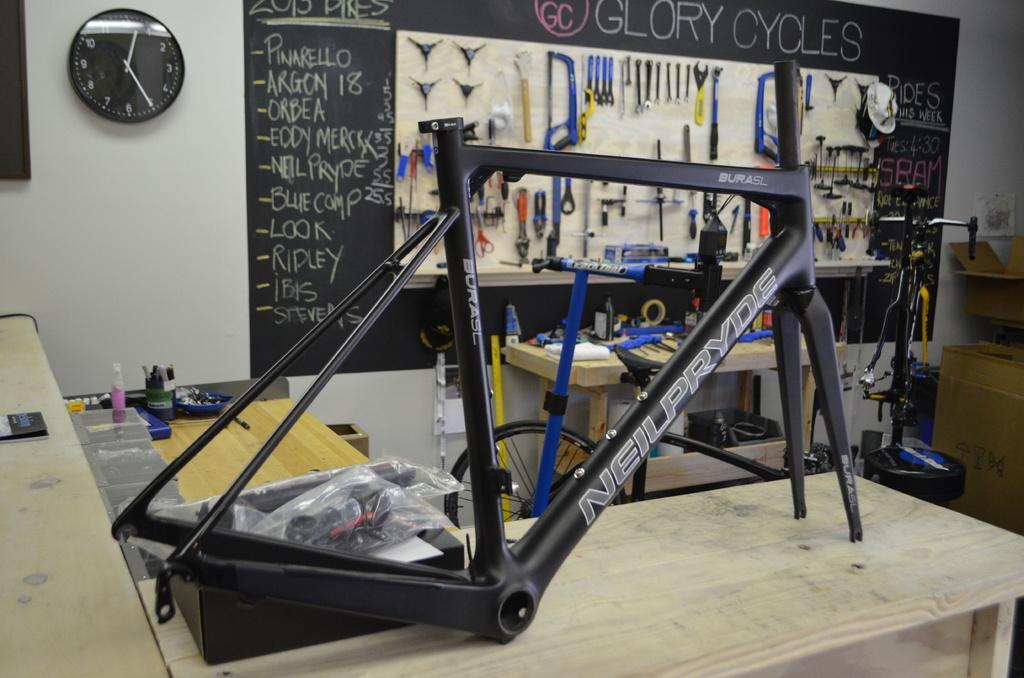In one or two sentences, can you explain what this image depicts? In this image we can see the bicycle frame which is placed on top of the table. And we can see clock hanging on the wall. And the background is like a black and some text is written on it. And right side, we can see the other bicycle frame which is in vertical position. 